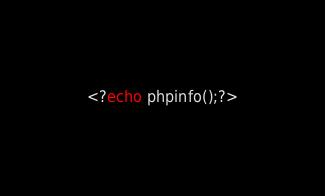Convert code to text. <code><loc_0><loc_0><loc_500><loc_500><_PHP_><?echo phpinfo();?></code> 